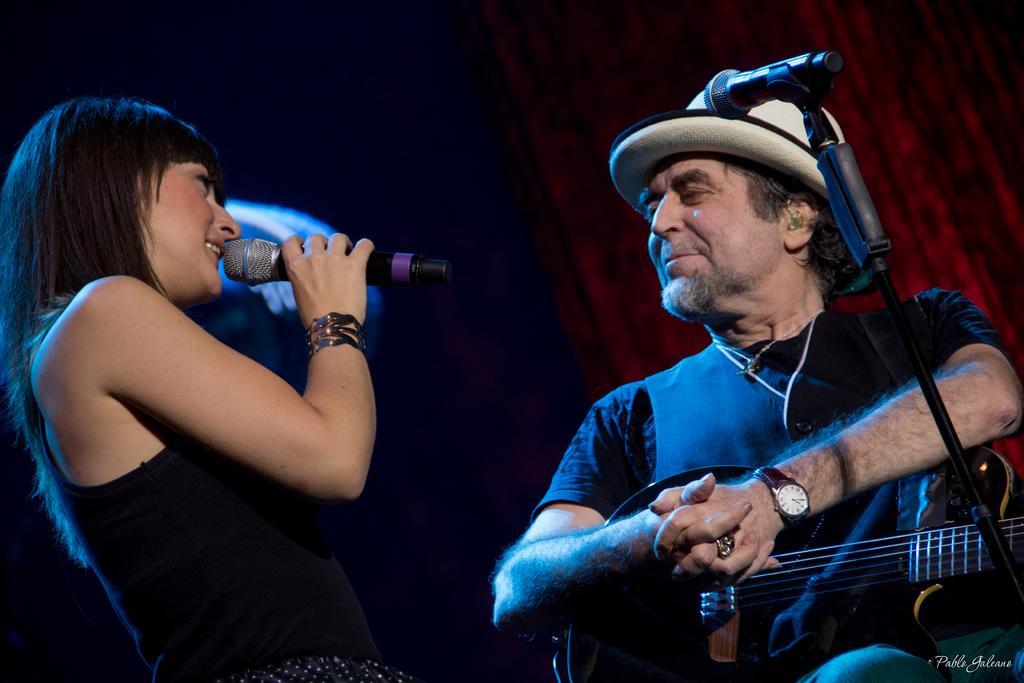How would you summarize this image in a sentence or two? In this image i can see a woman standing and singing in front of a micro phone wearing a black dress at right the man standing and smiling holding a guitar, there is a micro phone in front of him, at the background i can see a maroon curtain. A man wearing a watch and ring. 